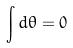<formula> <loc_0><loc_0><loc_500><loc_500>\int d \theta = 0</formula> 